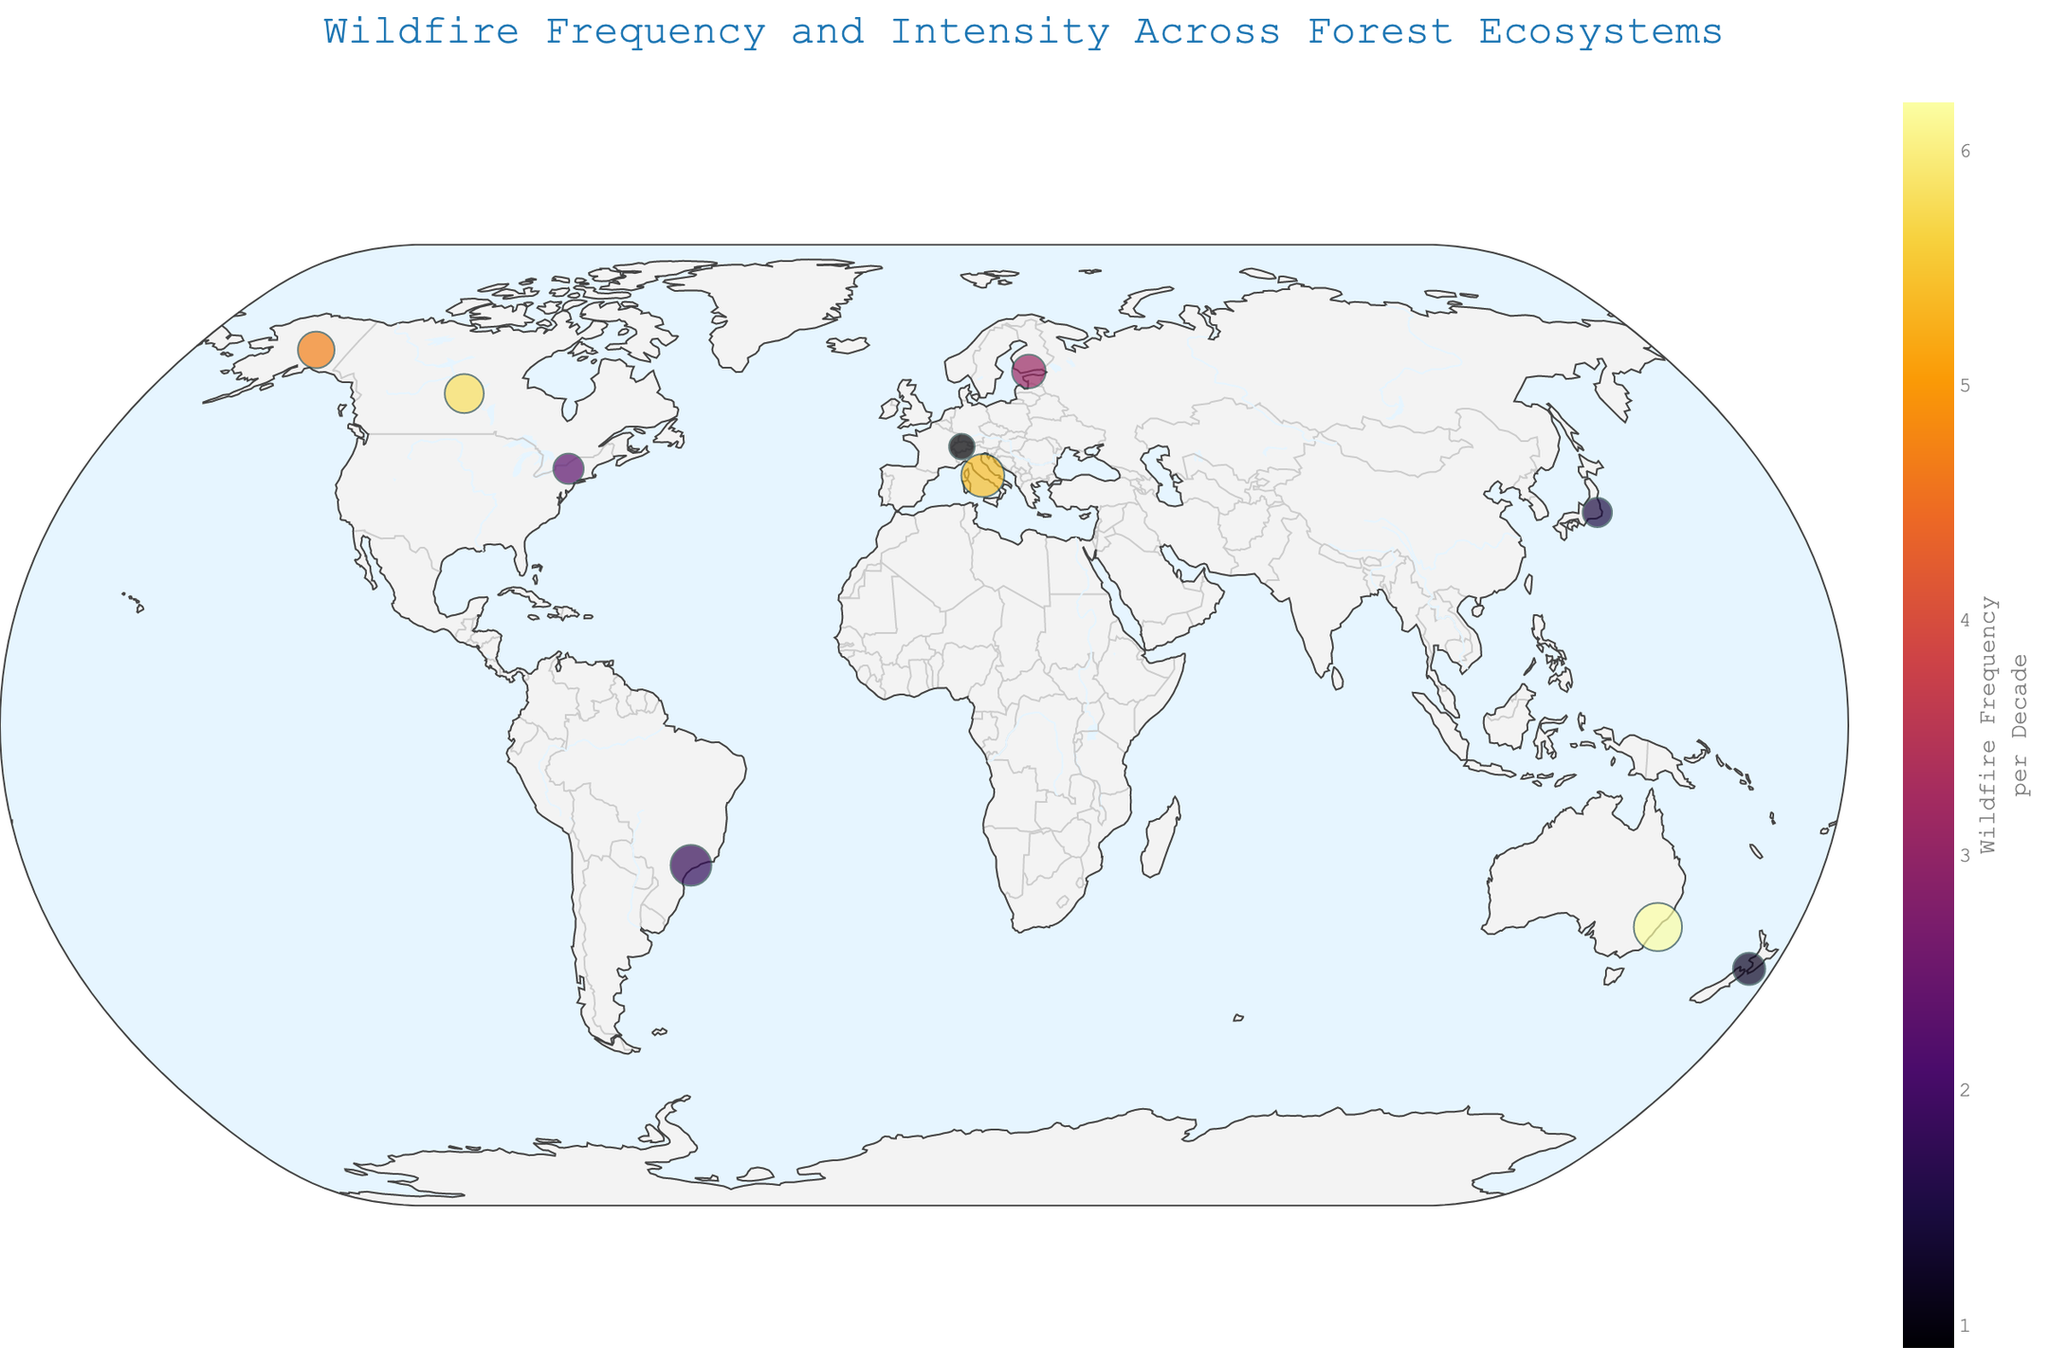What is the title of the map? The title is displayed at the top center of the map. It reads "Wildfire Frequency and Intensity Across Forest Ecosystems."
Answer: Wildfire Frequency and Intensity Across Forest Ecosystems What color scale is used to represent wildfire frequency? The color scale used is a sequential color scale called "Inferno," which ranges from light to dark colors as the frequency increases.
Answer: Inferno How are the markers representing wildfire data customized? The markers are customized with a dark outline, and their size varies according to the Intensity Score values, enhancing visibility and differentiation between data points.
Answer: Dark outline and varied size by Intensity Score Which country has the highest wildfire intensity score? By examining the size of the markers, Australia has the largest marker, indicating the highest intensity score of 7.8 as seen in the hover information.
Answer: Australia What is the wildfire frequency in Italy per decade? By looking at the hover information for Italy, the wildfire frequency per decade is found to be 5.4.
Answer: 5.4 Which forest ecosystem in the USA experiences the most frequent wildfires? The USA has two data points: Temperate Deciduous and Boreal. The Boreal ecosystem has a frequency of 4.7, which is higher than the 2.3 of Temperate Deciduous.
Answer: Boreal What is the average Climate Change Impact score across all locations? Adding all Climate Change Impact scores (0.8 + 1.5 + 2.1 + 1.7 + 1.9 + 1.2 + 0.7 + 0.6 + 0.9 + 1.8) and dividing by 10 (number of data points), the average calculation is (13.2 / 10).
Answer: 1.32 Compare the wildfire frequency between Temperate Deciduous forests in the USA and Temperate Mixed forests in Japan. Which has a lower frequency? The Temperate Mixed forests in Japan have a wildfire frequency of 1.5, whereas Temperate Deciduous forests in the USA have a frequency of 2.3. Therefore, Japan has a lower frequency.
Answer: Japan (1.5) Which countries have a Climate Change Impact score greater than 1.5? By checking each data point, Australia (2.1), Brazil (1.7), Italy (1.9), and Canada (1.8) have Climate Change Impact scores greater than 1.5.
Answer: Australia, Brazil, Italy, Canada What is the relationship between wildfire intensity and climate change impact in the boreal forests represented on the map? Boreal forests are in the USA, Finland, and Canada. The intensities are 4.5, 3.8, and 5.1, and their Climate Change Impact scores are 1.5, 1.2, and 1.8 respectively. Generally, a higher intensity correlates to a higher Climate Change Impact.
Answer: Higher intensity, higher impact 